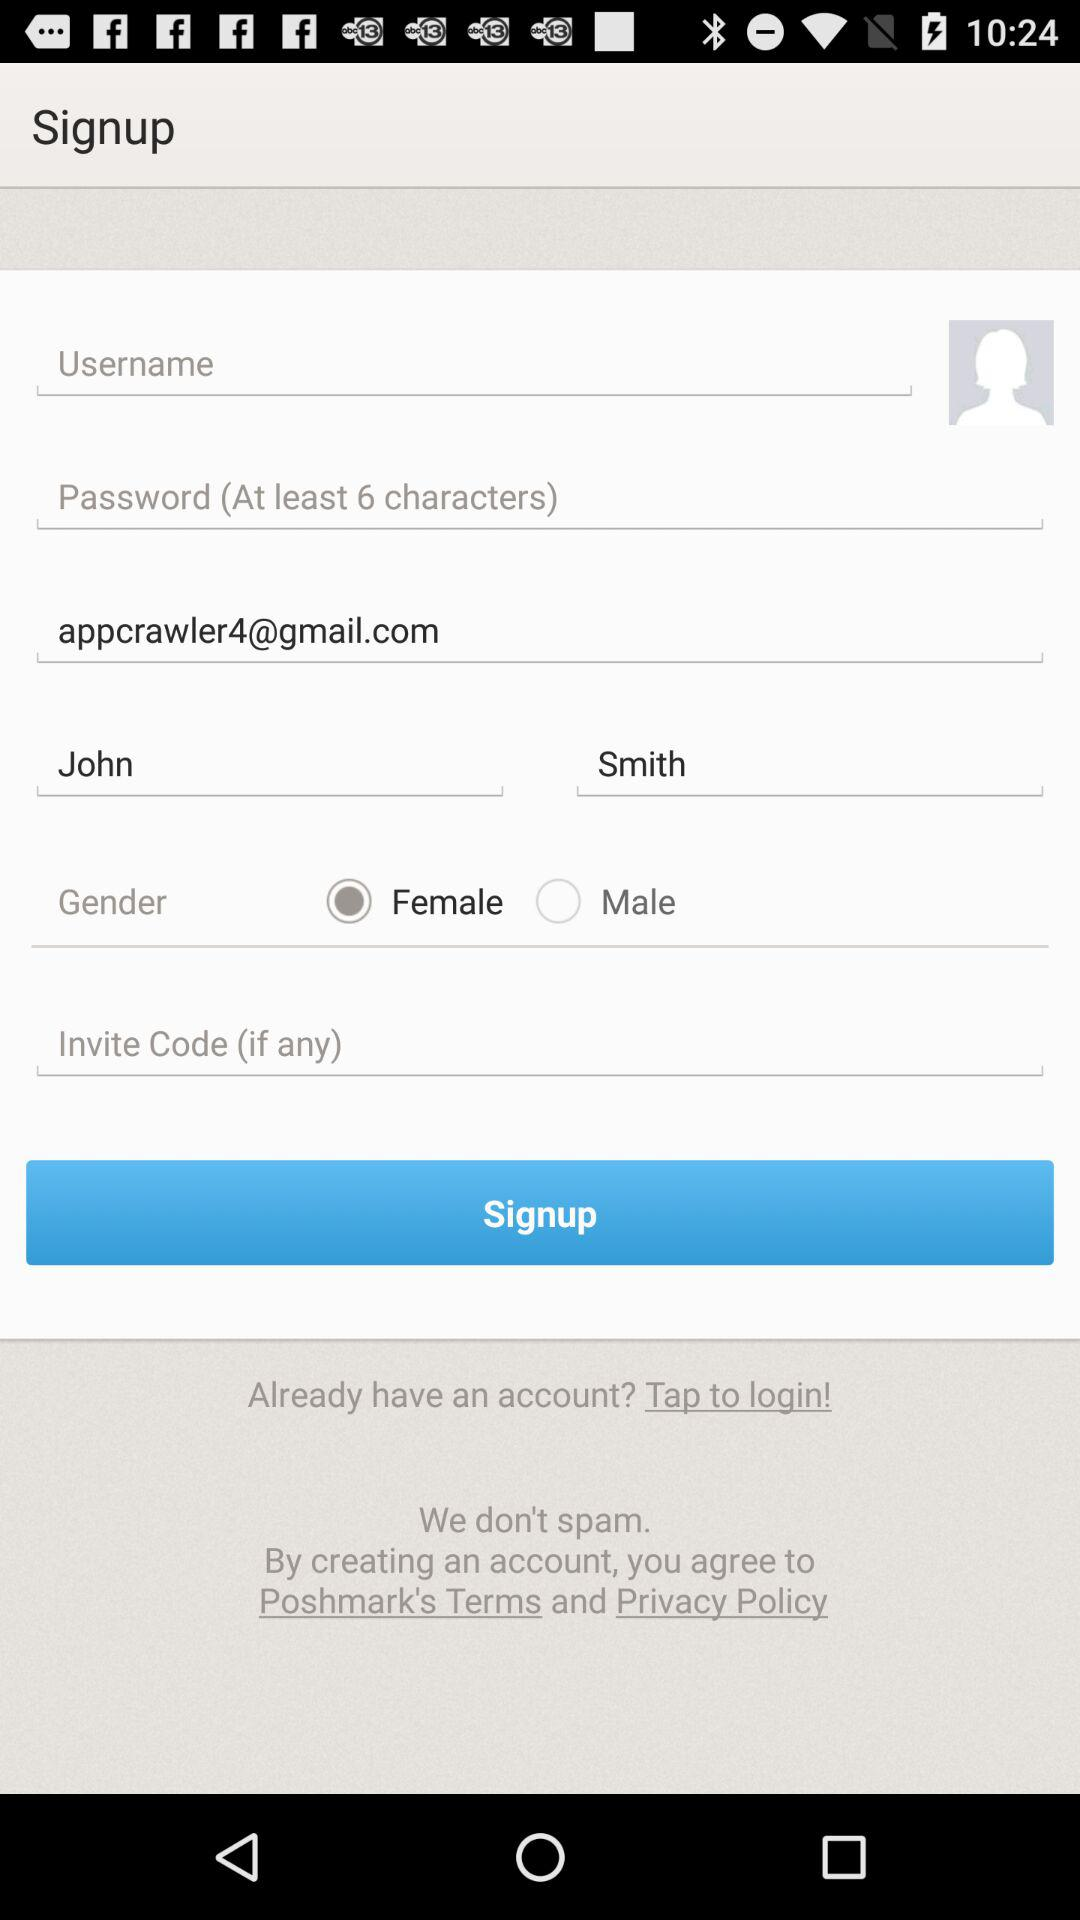What is the user's first name? The user's first name is John. 